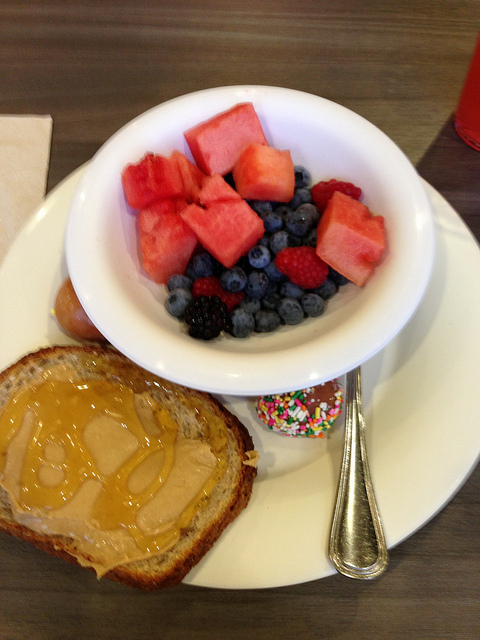<image>Are there any beverages in this scene? It is ambiguous if there are any beverages in this scene. It mostly seems like there are no beverages seen. Are there any beverages in this scene? Yes, there are beverages in this scene. 